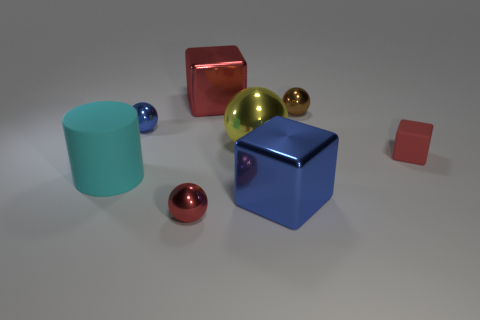How many big metallic objects have the same color as the large sphere?
Offer a very short reply. 0. What number of other objects are the same shape as the big red metal object?
Ensure brevity in your answer.  2. Is the number of small yellow metallic things greater than the number of big metallic cubes?
Your answer should be compact. No. What size is the metallic sphere behind the blue thing that is left of the blue metallic object right of the big red object?
Your answer should be very brief. Small. There is a cube behind the red rubber block; what size is it?
Provide a succinct answer. Large. How many things are either blue cubes or red things in front of the big rubber thing?
Your answer should be very brief. 2. What number of other objects are there of the same size as the cyan object?
Provide a succinct answer. 3. What is the material of the red thing that is the same shape as the small brown thing?
Make the answer very short. Metal. Is the number of spheres behind the big yellow object greater than the number of big blue metal cubes?
Make the answer very short. Yes. Is there anything else of the same color as the rubber block?
Your answer should be very brief. Yes. 